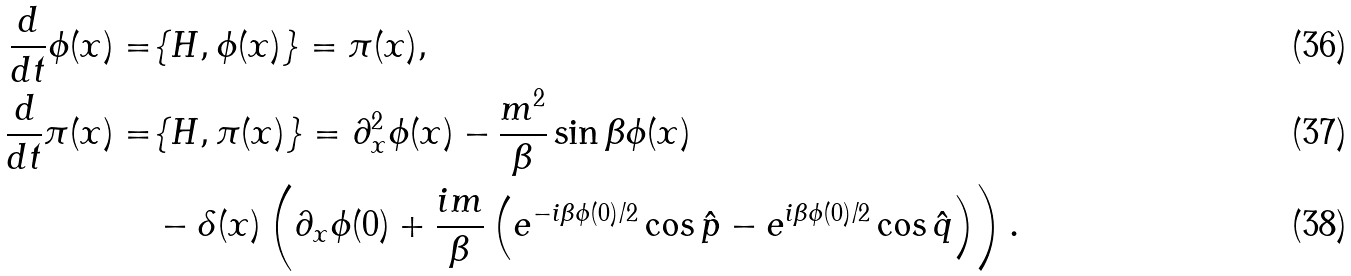<formula> <loc_0><loc_0><loc_500><loc_500>\frac { d } { d t } \phi ( x ) = & \{ H , \phi ( x ) \} = \pi ( x ) , \\ \frac { d } { d t } \pi ( x ) = & \{ H , \pi ( x ) \} = \partial _ { x } ^ { 2 } \phi ( x ) - \frac { m ^ { 2 } } { \beta } \sin \beta \phi ( x ) \\ & - \delta ( x ) \left ( \partial _ { x } \phi ( 0 ) + \frac { i m } { \beta } \left ( e ^ { - i \beta \phi ( 0 ) / 2 } \cos \hat { p } - e ^ { i \beta \phi ( 0 ) / 2 } \cos \hat { q } \right ) \right ) .</formula> 